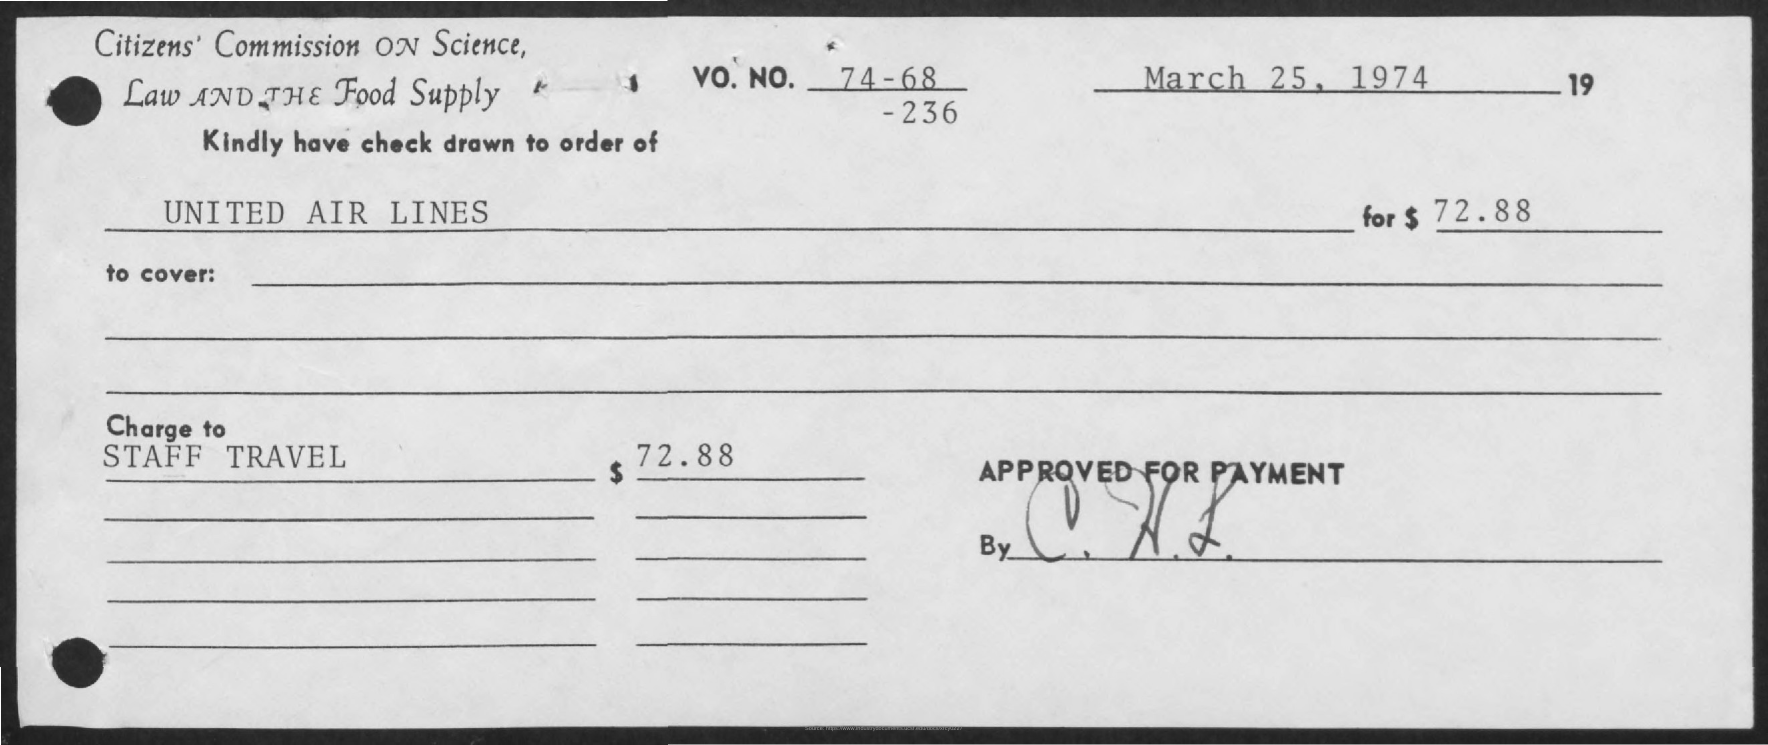When is the Memorandum dated on ?
Offer a very short reply. March 25, 1974. 